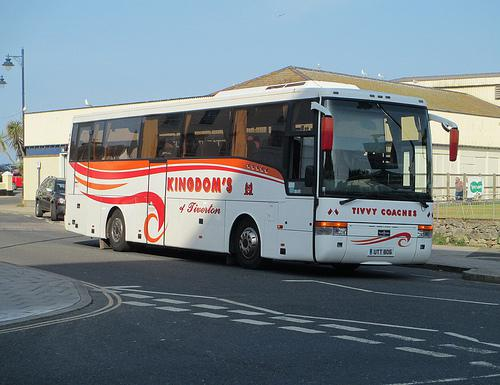Question: what color is the bus?
Choices:
A. Yellow and black.
B. Green and white.
C. Red and white.
D. Blue and gold.
Answer with the letter. Answer: C Question: when does the bus stop?
Choices:
A. At red lights.
B. When it drops people off and picks people up.
C. At stop signs.
D. At the bus station.
Answer with the letter. Answer: B Question: what is on the other side of the bus?
Choices:
A. A car.
B. A stop sign.
C. A bicyclist.
D. A building.
Answer with the letter. Answer: D Question: where is there a car?
Choices:
A. Parking garage.
B. Car dealership.
C. At the mechanic.
D. Behind the bus.
Answer with the letter. Answer: D Question: how many people are in the crosswalk?
Choices:
A. One.
B. Two.
C. Three.
D. Zero.
Answer with the letter. Answer: D 